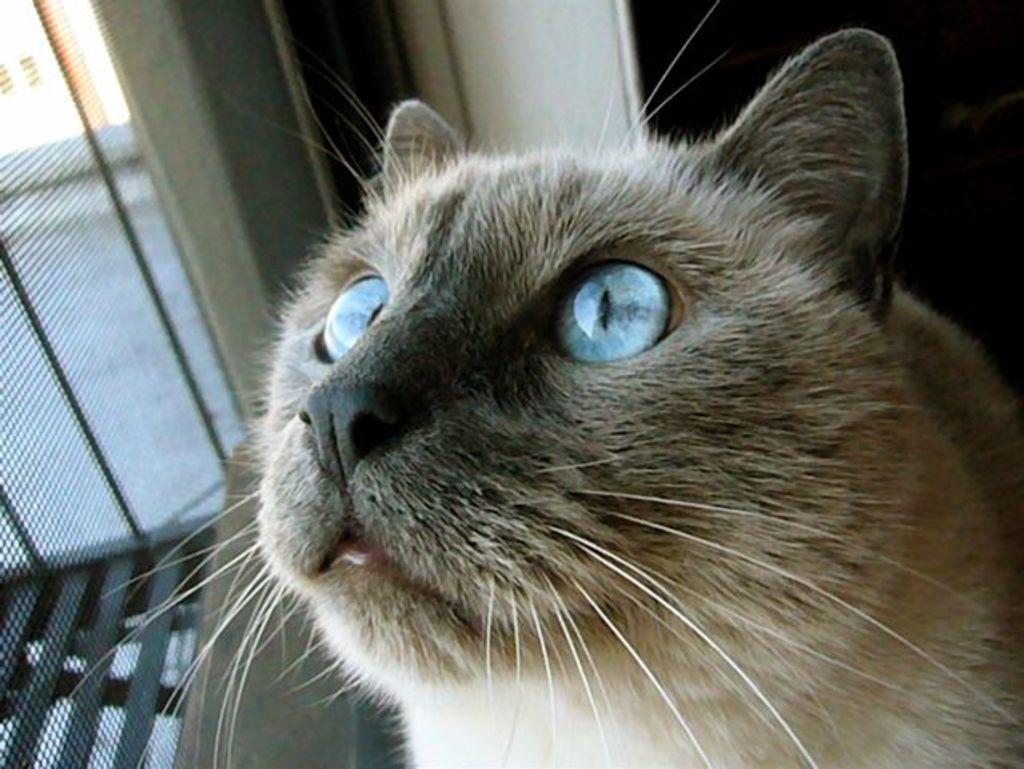In one or two sentences, can you explain what this image depicts? In this image I can see the cat which is in cream and black color. In the background I can see the wall and the net window. 